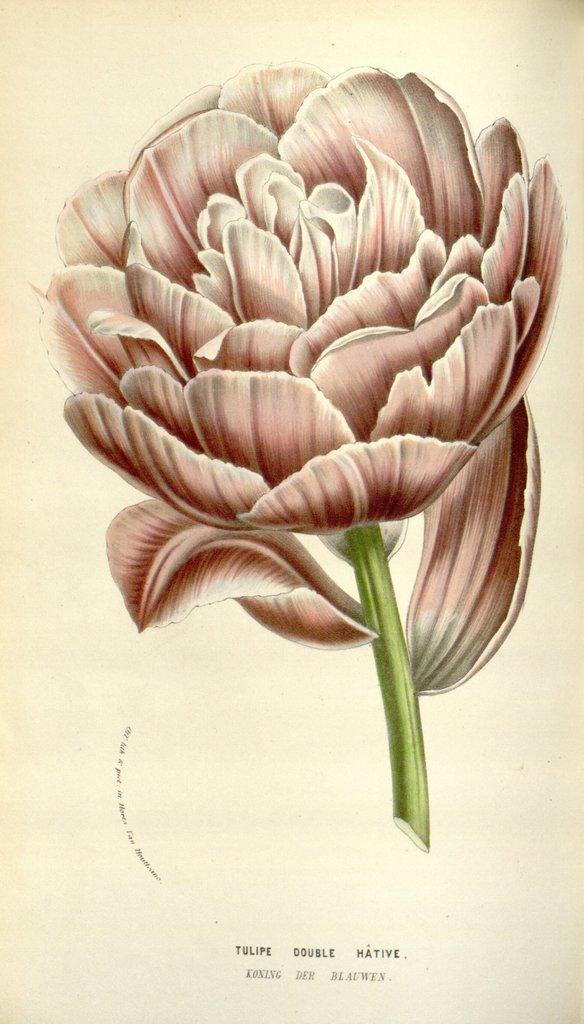What is the main subject of the image? The main subject of the image is a painted flower. What color is the stem of the flower? The stem of the flower is in green color. What type of ticket can be seen in the image? There is no ticket present in the image; it features a painted flower with a green stem. 